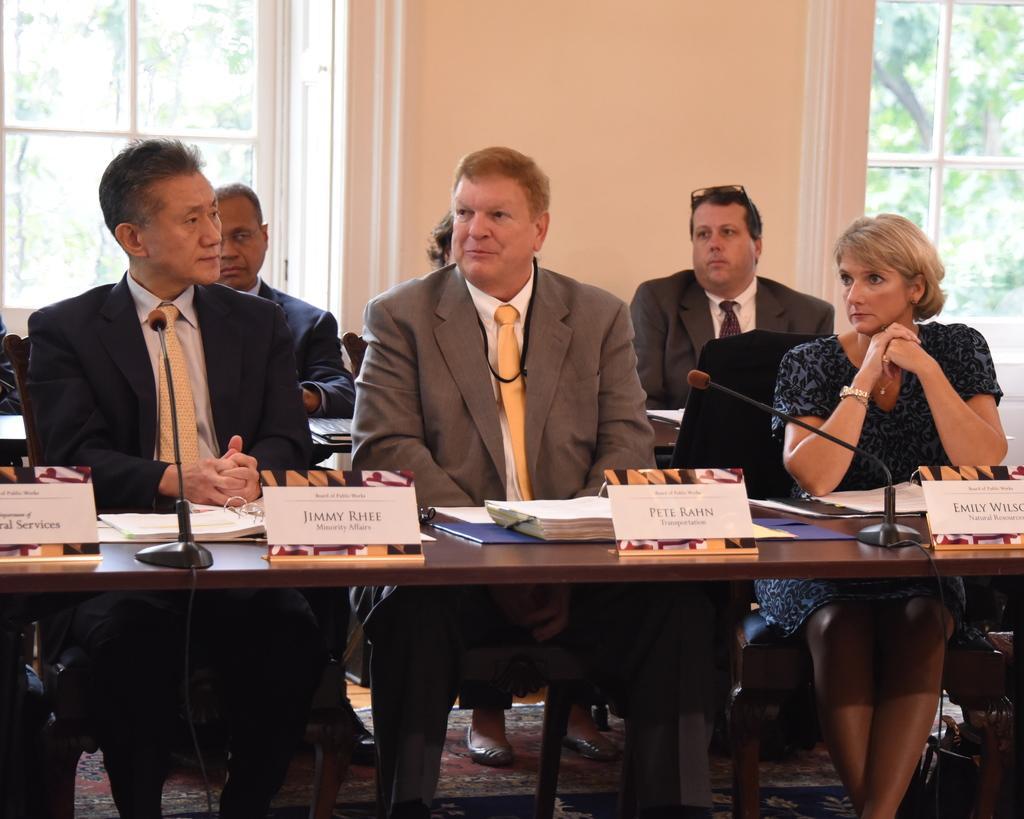Please provide a concise description of this image. In this picture we can see some persons sitting on chair and in front of them there is table and on table we can see name boards, mic, book and in the background we can see wall, windows, trees. 